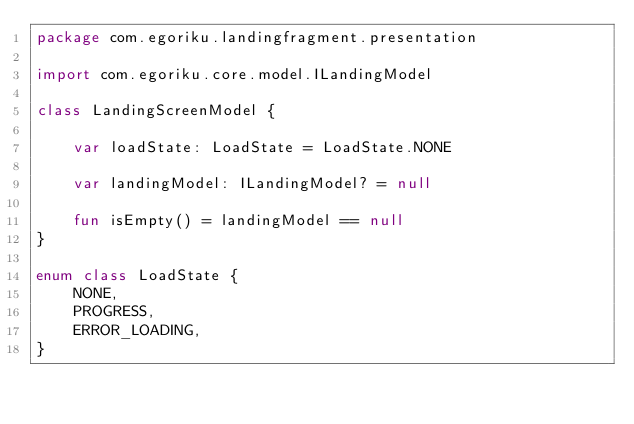<code> <loc_0><loc_0><loc_500><loc_500><_Kotlin_>package com.egoriku.landingfragment.presentation

import com.egoriku.core.model.ILandingModel

class LandingScreenModel {

    var loadState: LoadState = LoadState.NONE

    var landingModel: ILandingModel? = null

    fun isEmpty() = landingModel == null
}

enum class LoadState {
    NONE,
    PROGRESS,
    ERROR_LOADING,
}</code> 